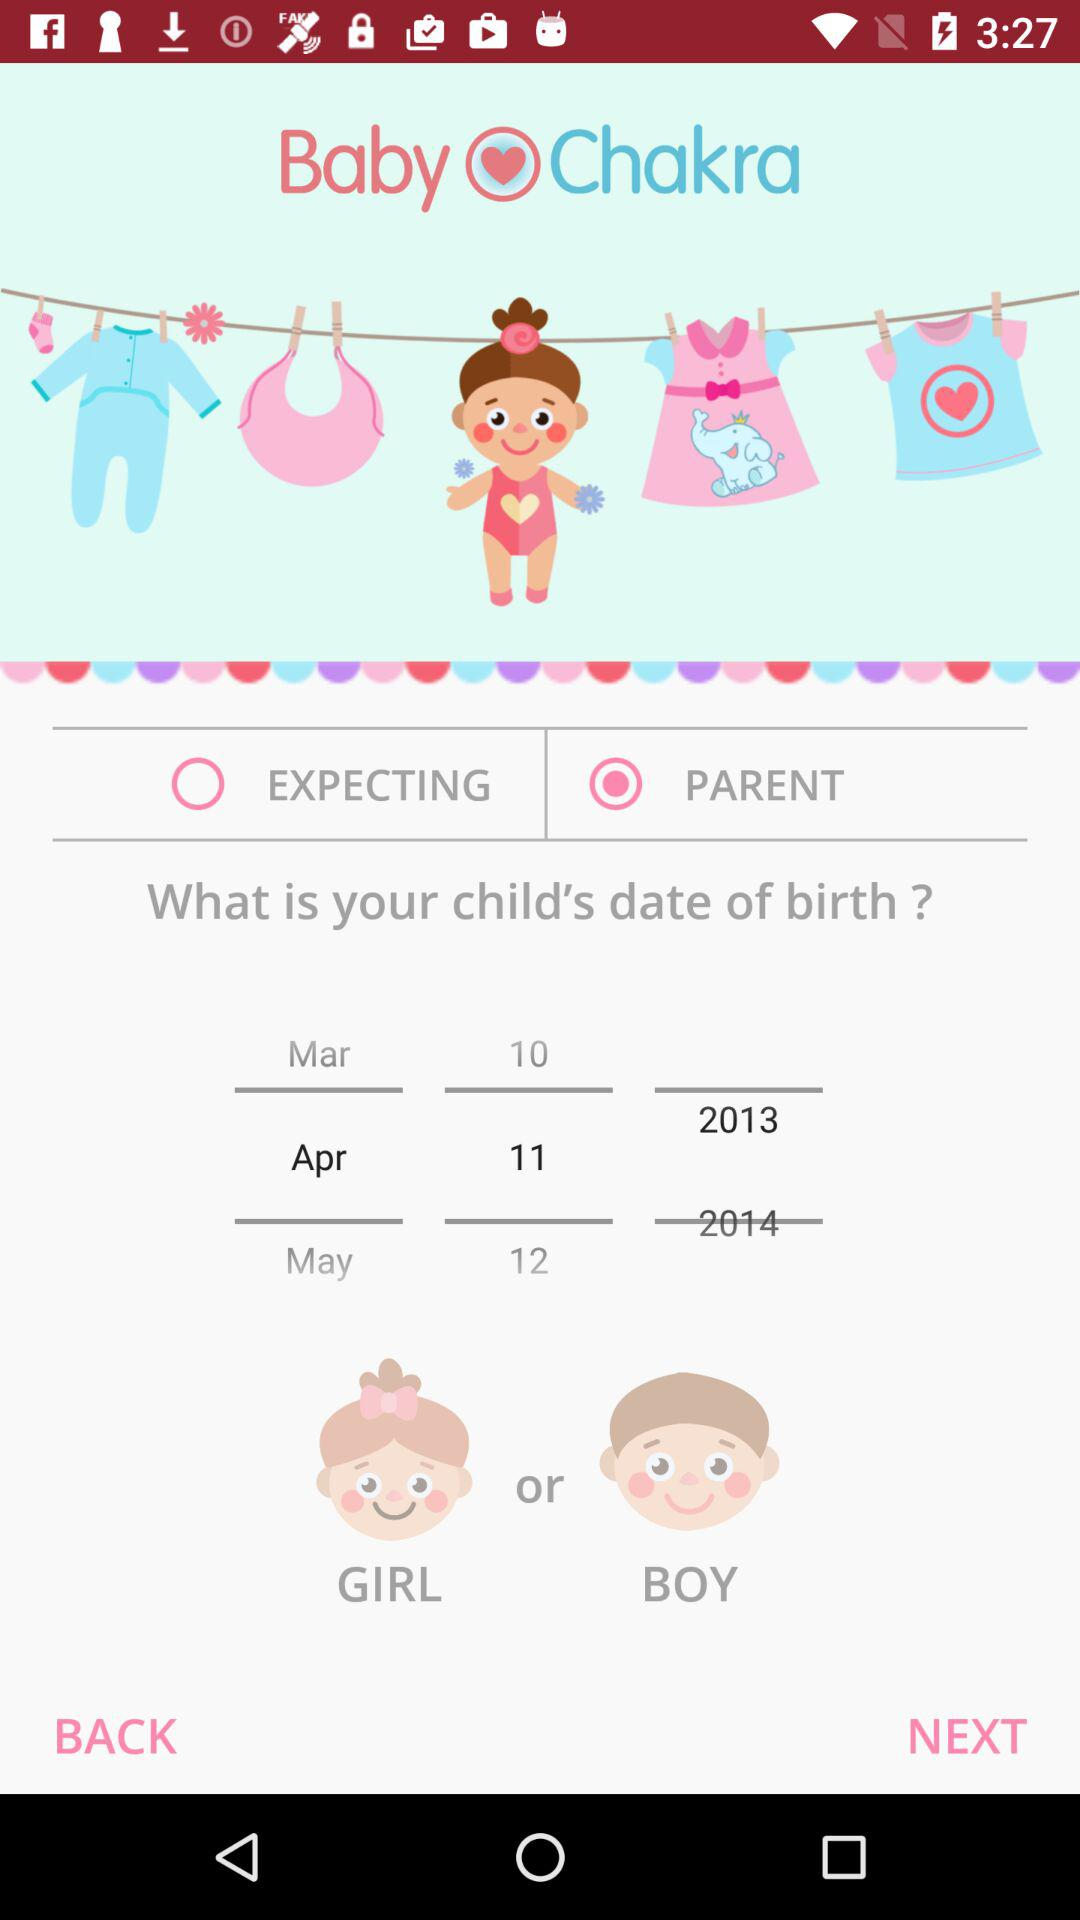Which option is selected? The selected option is "PARENT". 